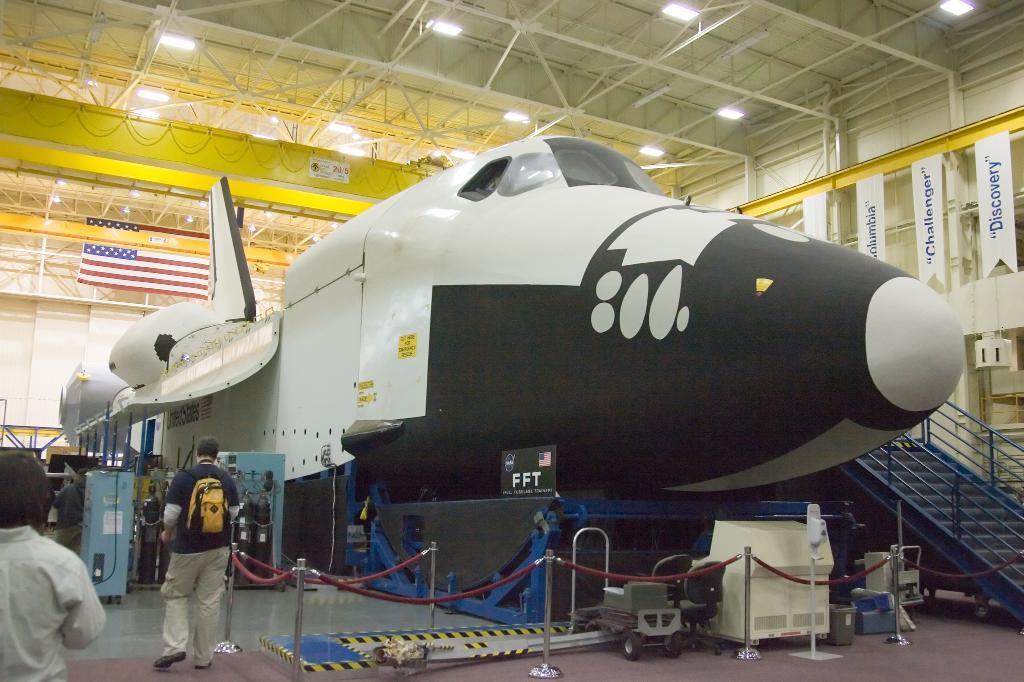Please provide a concise description of this image. In the image there is an aircraft inside a godown with fence around it and steps on the right side and few people walking on the left side, there are lights over the ceiling. 